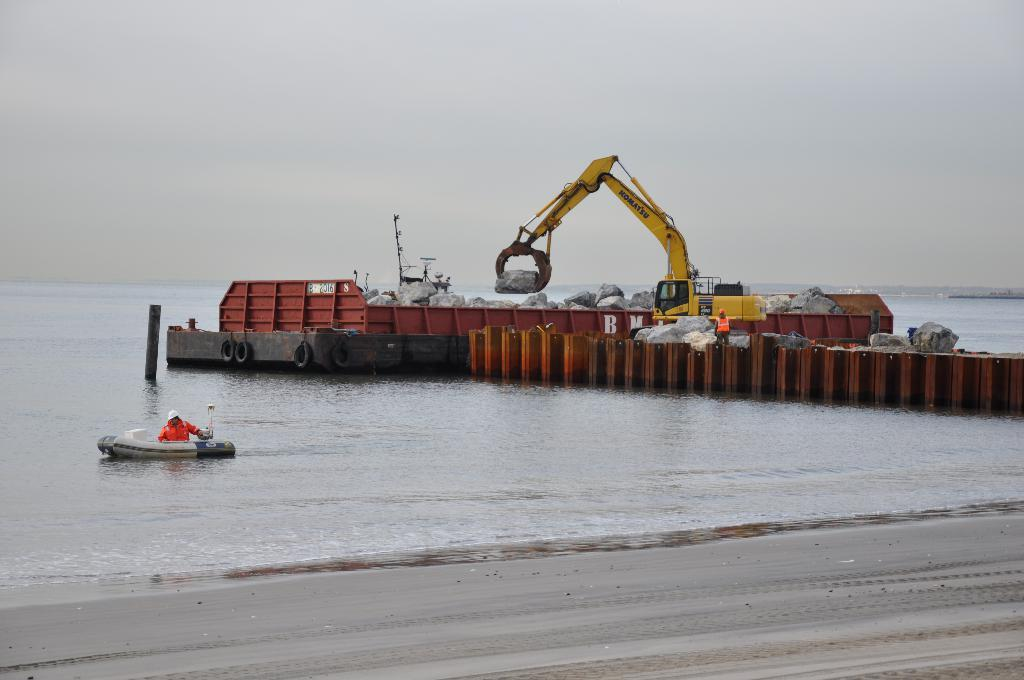What is the person in the image doing? The person is inside a boat in the image. What other objects can be seen in the image? There is a crane, stones, water, and another boat in the image. What is the color of the sky in the image? The sky appears to be white in color. What is the brown color object in the image? The brown color object in the image is not specified, but it could be a part of the boat, crane, or another object. How many children are playing with the monkey in the image? There are no children or monkeys present in the image. 